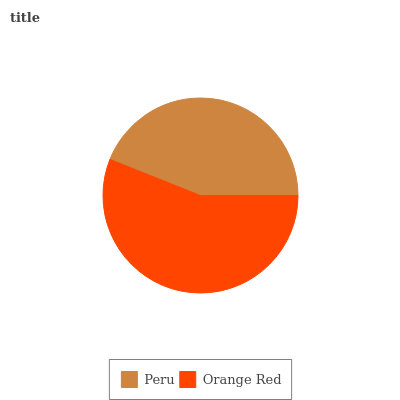Is Peru the minimum?
Answer yes or no. Yes. Is Orange Red the maximum?
Answer yes or no. Yes. Is Orange Red the minimum?
Answer yes or no. No. Is Orange Red greater than Peru?
Answer yes or no. Yes. Is Peru less than Orange Red?
Answer yes or no. Yes. Is Peru greater than Orange Red?
Answer yes or no. No. Is Orange Red less than Peru?
Answer yes or no. No. Is Orange Red the high median?
Answer yes or no. Yes. Is Peru the low median?
Answer yes or no. Yes. Is Peru the high median?
Answer yes or no. No. Is Orange Red the low median?
Answer yes or no. No. 